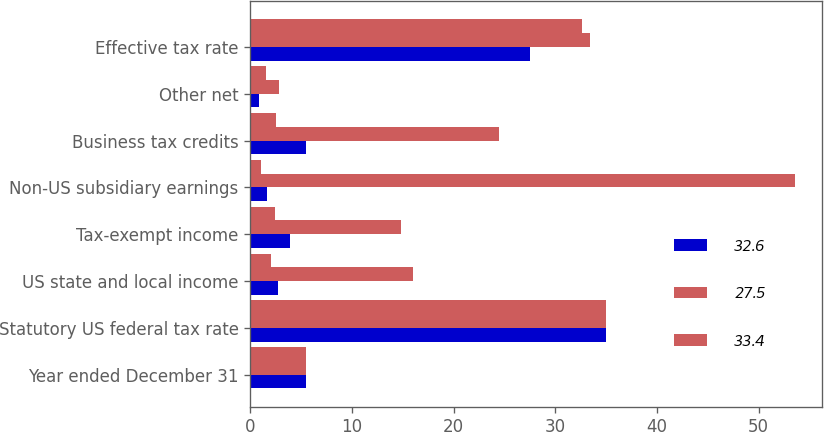Convert chart to OTSL. <chart><loc_0><loc_0><loc_500><loc_500><stacked_bar_chart><ecel><fcel>Year ended December 31<fcel>Statutory US federal tax rate<fcel>US state and local income<fcel>Tax-exempt income<fcel>Non-US subsidiary earnings<fcel>Business tax credits<fcel>Other net<fcel>Effective tax rate<nl><fcel>32.6<fcel>5.5<fcel>35<fcel>2.7<fcel>3.9<fcel>1.7<fcel>5.5<fcel>0.9<fcel>27.5<nl><fcel>27.5<fcel>5.5<fcel>35<fcel>16<fcel>14.8<fcel>53.6<fcel>24.5<fcel>2.8<fcel>33.4<nl><fcel>33.4<fcel>5.5<fcel>35<fcel>2<fcel>2.4<fcel>1.1<fcel>2.5<fcel>1.6<fcel>32.6<nl></chart> 